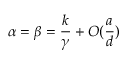<formula> <loc_0><loc_0><loc_500><loc_500>\alpha = \beta = \frac { k } { \gamma } + O ( \frac { a } { d } )</formula> 